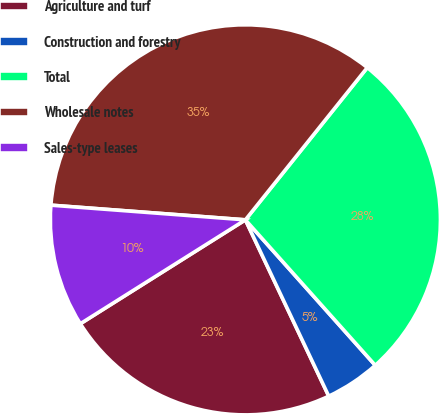Convert chart. <chart><loc_0><loc_0><loc_500><loc_500><pie_chart><fcel>Agriculture and turf<fcel>Construction and forestry<fcel>Total<fcel>Wholesale notes<fcel>Sales-type leases<nl><fcel>23.09%<fcel>4.57%<fcel>27.66%<fcel>34.55%<fcel>10.14%<nl></chart> 